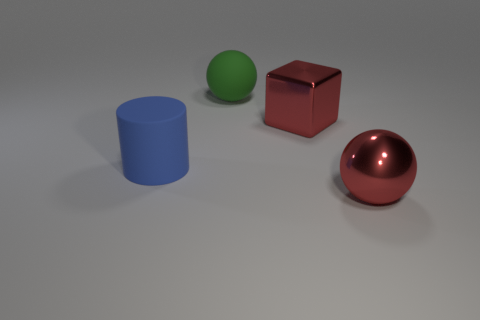What number of cylinders are either blue objects or red shiny things?
Ensure brevity in your answer.  1. There is a rubber thing that is behind the red shiny thing behind the large matte cylinder; what is its color?
Provide a succinct answer. Green. Is the number of green things that are in front of the big blue cylinder less than the number of rubber objects in front of the big matte sphere?
Keep it short and to the point. Yes. What is the shape of the object that is on the right side of the big green rubber thing and left of the metal ball?
Keep it short and to the point. Cube. How many big things are to the left of the red metallic thing that is in front of the big red block?
Provide a succinct answer. 3. Does the large thing that is on the left side of the green matte thing have the same material as the big green sphere?
Provide a short and direct response. Yes. There is a ball that is on the right side of the sphere that is behind the ball that is to the right of the large green rubber sphere; what size is it?
Provide a succinct answer. Large. There is a large thing on the right side of the big red shiny cube; does it have the same shape as the big matte object on the right side of the big blue cylinder?
Give a very brief answer. Yes. What number of other things are there of the same color as the large metallic block?
Ensure brevity in your answer.  1. Do the large red thing in front of the large rubber cylinder and the big ball that is behind the big blue rubber object have the same material?
Offer a terse response. No. 